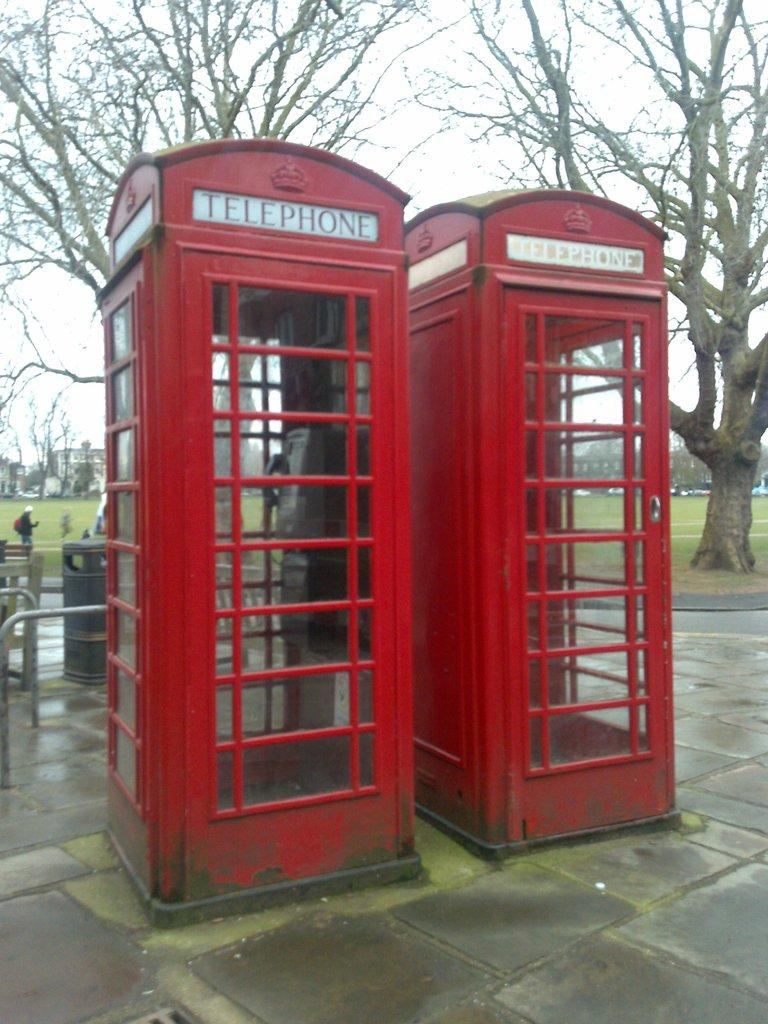What structures are located in the center of the image? There are telephone booths in the center of the image. What can be seen in the background of the image? There is a bin, trees, a building, and the sky visible in the background of the image. What type of curtain is hanging in the telephone booths in the image? There are no curtains present in the telephone booths or the image. 